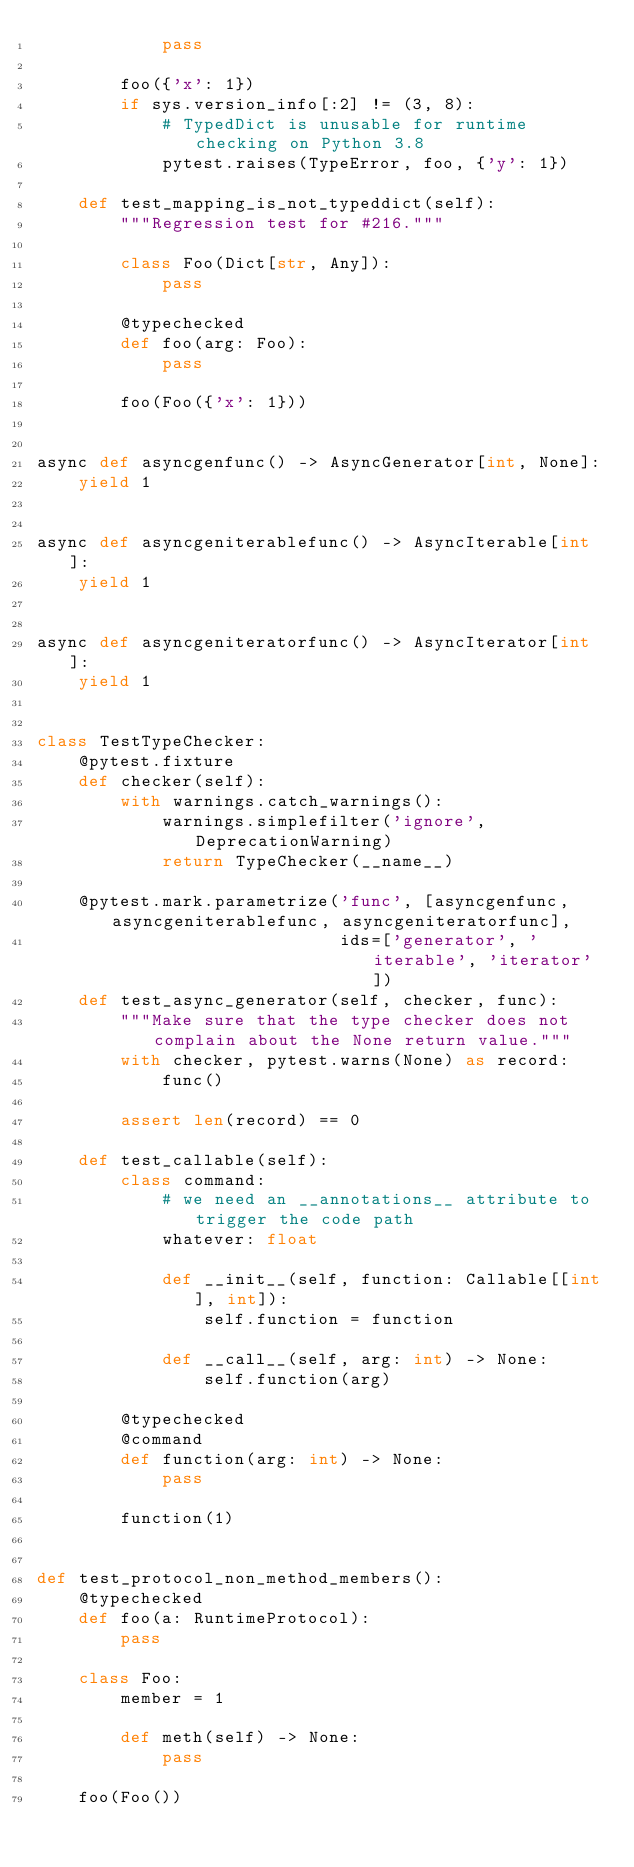<code> <loc_0><loc_0><loc_500><loc_500><_Python_>            pass

        foo({'x': 1})
        if sys.version_info[:2] != (3, 8):
            # TypedDict is unusable for runtime checking on Python 3.8
            pytest.raises(TypeError, foo, {'y': 1})

    def test_mapping_is_not_typeddict(self):
        """Regression test for #216."""

        class Foo(Dict[str, Any]):
            pass

        @typechecked
        def foo(arg: Foo):
            pass

        foo(Foo({'x': 1}))


async def asyncgenfunc() -> AsyncGenerator[int, None]:
    yield 1


async def asyncgeniterablefunc() -> AsyncIterable[int]:
    yield 1


async def asyncgeniteratorfunc() -> AsyncIterator[int]:
    yield 1


class TestTypeChecker:
    @pytest.fixture
    def checker(self):
        with warnings.catch_warnings():
            warnings.simplefilter('ignore', DeprecationWarning)
            return TypeChecker(__name__)

    @pytest.mark.parametrize('func', [asyncgenfunc, asyncgeniterablefunc, asyncgeniteratorfunc],
                             ids=['generator', 'iterable', 'iterator'])
    def test_async_generator(self, checker, func):
        """Make sure that the type checker does not complain about the None return value."""
        with checker, pytest.warns(None) as record:
            func()

        assert len(record) == 0

    def test_callable(self):
        class command:
            # we need an __annotations__ attribute to trigger the code path
            whatever: float

            def __init__(self, function: Callable[[int], int]):
                self.function = function

            def __call__(self, arg: int) -> None:
                self.function(arg)

        @typechecked
        @command
        def function(arg: int) -> None:
            pass

        function(1)


def test_protocol_non_method_members():
    @typechecked
    def foo(a: RuntimeProtocol):
        pass

    class Foo:
        member = 1

        def meth(self) -> None:
            pass

    foo(Foo())
</code> 